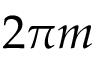Convert formula to latex. <formula><loc_0><loc_0><loc_500><loc_500>2 \pi m</formula> 